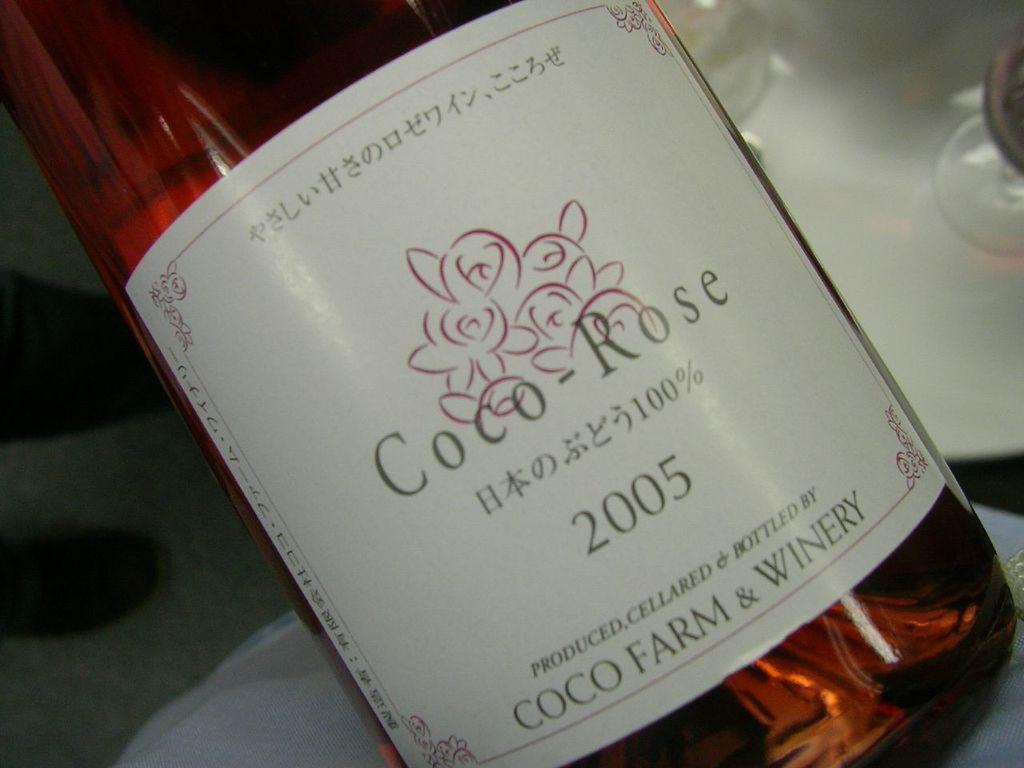Provide a one-sentence caption for the provided image. The alcohol is labeled Rose in the image. 